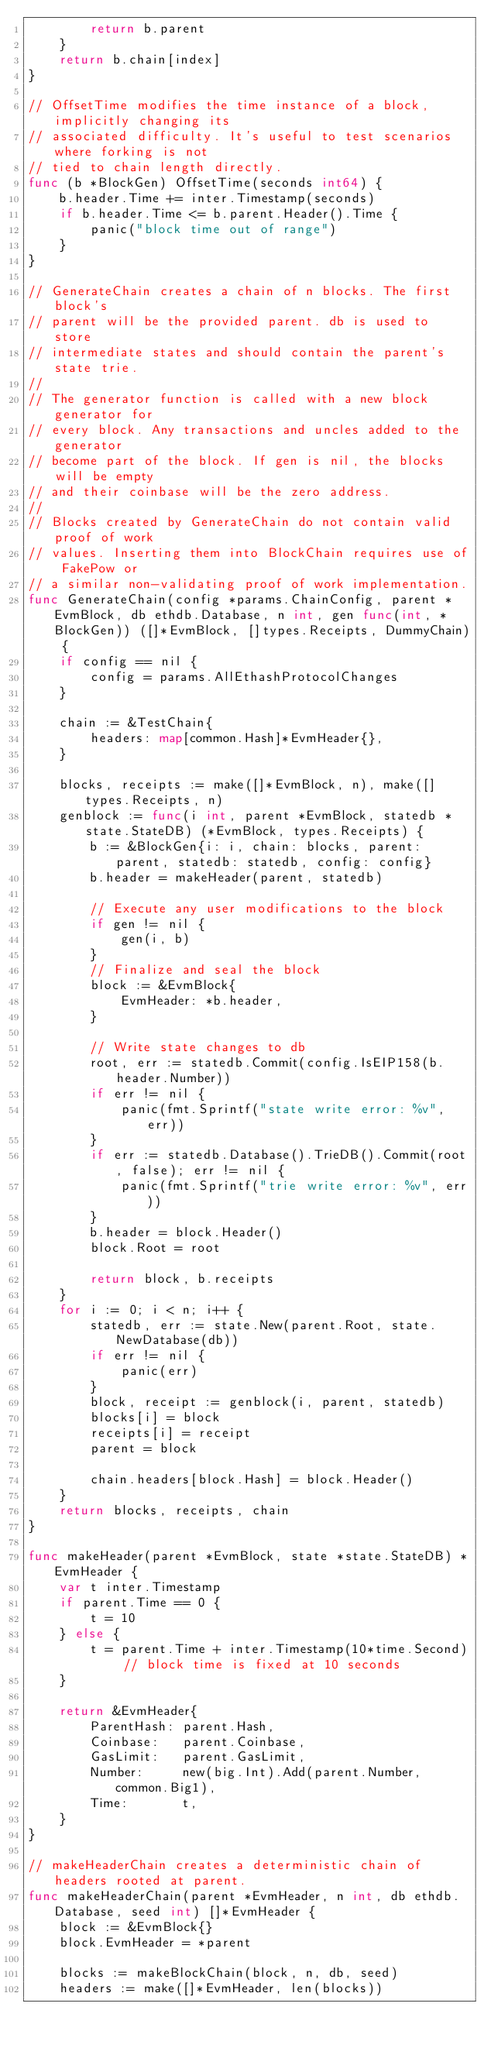Convert code to text. <code><loc_0><loc_0><loc_500><loc_500><_Go_>		return b.parent
	}
	return b.chain[index]
}

// OffsetTime modifies the time instance of a block, implicitly changing its
// associated difficulty. It's useful to test scenarios where forking is not
// tied to chain length directly.
func (b *BlockGen) OffsetTime(seconds int64) {
	b.header.Time += inter.Timestamp(seconds)
	if b.header.Time <= b.parent.Header().Time {
		panic("block time out of range")
	}
}

// GenerateChain creates a chain of n blocks. The first block's
// parent will be the provided parent. db is used to store
// intermediate states and should contain the parent's state trie.
//
// The generator function is called with a new block generator for
// every block. Any transactions and uncles added to the generator
// become part of the block. If gen is nil, the blocks will be empty
// and their coinbase will be the zero address.
//
// Blocks created by GenerateChain do not contain valid proof of work
// values. Inserting them into BlockChain requires use of FakePow or
// a similar non-validating proof of work implementation.
func GenerateChain(config *params.ChainConfig, parent *EvmBlock, db ethdb.Database, n int, gen func(int, *BlockGen)) ([]*EvmBlock, []types.Receipts, DummyChain) {
	if config == nil {
		config = params.AllEthashProtocolChanges
	}

	chain := &TestChain{
		headers: map[common.Hash]*EvmHeader{},
	}

	blocks, receipts := make([]*EvmBlock, n), make([]types.Receipts, n)
	genblock := func(i int, parent *EvmBlock, statedb *state.StateDB) (*EvmBlock, types.Receipts) {
		b := &BlockGen{i: i, chain: blocks, parent: parent, statedb: statedb, config: config}
		b.header = makeHeader(parent, statedb)

		// Execute any user modifications to the block
		if gen != nil {
			gen(i, b)
		}
		// Finalize and seal the block
		block := &EvmBlock{
			EvmHeader: *b.header,
		}

		// Write state changes to db
		root, err := statedb.Commit(config.IsEIP158(b.header.Number))
		if err != nil {
			panic(fmt.Sprintf("state write error: %v", err))
		}
		if err := statedb.Database().TrieDB().Commit(root, false); err != nil {
			panic(fmt.Sprintf("trie write error: %v", err))
		}
		b.header = block.Header()
		block.Root = root

		return block, b.receipts
	}
	for i := 0; i < n; i++ {
		statedb, err := state.New(parent.Root, state.NewDatabase(db))
		if err != nil {
			panic(err)
		}
		block, receipt := genblock(i, parent, statedb)
		blocks[i] = block
		receipts[i] = receipt
		parent = block

		chain.headers[block.Hash] = block.Header()
	}
	return blocks, receipts, chain
}

func makeHeader(parent *EvmBlock, state *state.StateDB) *EvmHeader {
	var t inter.Timestamp
	if parent.Time == 0 {
		t = 10
	} else {
		t = parent.Time + inter.Timestamp(10*time.Second) // block time is fixed at 10 seconds
	}

	return &EvmHeader{
		ParentHash: parent.Hash,
		Coinbase:   parent.Coinbase,
		GasLimit:   parent.GasLimit,
		Number:     new(big.Int).Add(parent.Number, common.Big1),
		Time:       t,
	}
}

// makeHeaderChain creates a deterministic chain of headers rooted at parent.
func makeHeaderChain(parent *EvmHeader, n int, db ethdb.Database, seed int) []*EvmHeader {
	block := &EvmBlock{}
	block.EvmHeader = *parent

	blocks := makeBlockChain(block, n, db, seed)
	headers := make([]*EvmHeader, len(blocks))</code> 